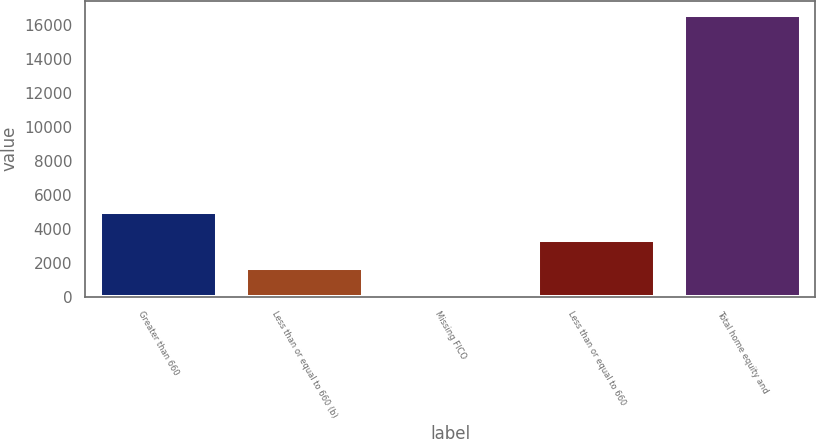Convert chart. <chart><loc_0><loc_0><loc_500><loc_500><bar_chart><fcel>Greater than 660<fcel>Less than or equal to 660 (b)<fcel>Missing FICO<fcel>Less than or equal to 660<fcel>Total home equity and<nl><fcel>4980.7<fcel>1660.9<fcel>1<fcel>3320.8<fcel>16600<nl></chart> 